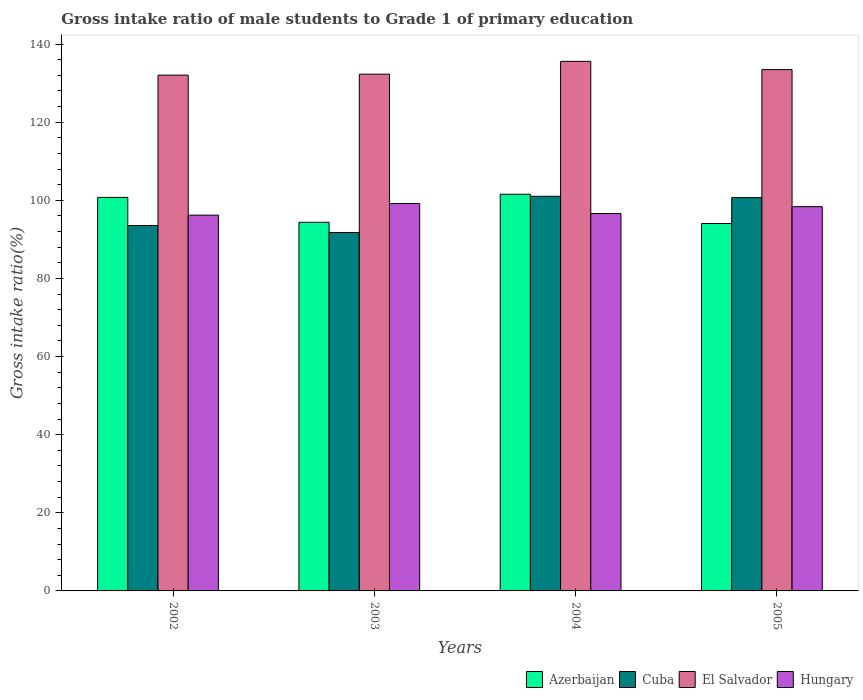How many groups of bars are there?
Make the answer very short. 4. Are the number of bars per tick equal to the number of legend labels?
Your answer should be very brief. Yes. Are the number of bars on each tick of the X-axis equal?
Provide a short and direct response. Yes. What is the gross intake ratio in Hungary in 2003?
Give a very brief answer. 99.19. Across all years, what is the maximum gross intake ratio in Cuba?
Your answer should be very brief. 101.04. Across all years, what is the minimum gross intake ratio in Cuba?
Provide a short and direct response. 91.77. In which year was the gross intake ratio in Hungary maximum?
Your answer should be very brief. 2003. In which year was the gross intake ratio in El Salvador minimum?
Offer a very short reply. 2002. What is the total gross intake ratio in Hungary in the graph?
Your answer should be compact. 390.42. What is the difference between the gross intake ratio in Cuba in 2003 and that in 2005?
Offer a very short reply. -8.93. What is the difference between the gross intake ratio in Azerbaijan in 2002 and the gross intake ratio in Hungary in 2004?
Provide a succinct answer. 4.13. What is the average gross intake ratio in El Salvador per year?
Make the answer very short. 133.36. In the year 2005, what is the difference between the gross intake ratio in Cuba and gross intake ratio in Azerbaijan?
Your response must be concise. 6.62. What is the ratio of the gross intake ratio in El Salvador in 2002 to that in 2005?
Offer a very short reply. 0.99. Is the gross intake ratio in Cuba in 2003 less than that in 2005?
Offer a very short reply. Yes. What is the difference between the highest and the second highest gross intake ratio in El Salvador?
Offer a very short reply. 2.11. What is the difference between the highest and the lowest gross intake ratio in El Salvador?
Your response must be concise. 3.52. Is the sum of the gross intake ratio in Azerbaijan in 2002 and 2003 greater than the maximum gross intake ratio in El Salvador across all years?
Your response must be concise. Yes. Is it the case that in every year, the sum of the gross intake ratio in Hungary and gross intake ratio in Cuba is greater than the sum of gross intake ratio in Azerbaijan and gross intake ratio in El Salvador?
Your response must be concise. No. What does the 4th bar from the left in 2004 represents?
Keep it short and to the point. Hungary. What does the 4th bar from the right in 2003 represents?
Your answer should be very brief. Azerbaijan. How many bars are there?
Give a very brief answer. 16. How many years are there in the graph?
Your answer should be very brief. 4. What is the difference between two consecutive major ticks on the Y-axis?
Your answer should be compact. 20. Are the values on the major ticks of Y-axis written in scientific E-notation?
Make the answer very short. No. Does the graph contain grids?
Your answer should be very brief. No. What is the title of the graph?
Offer a very short reply. Gross intake ratio of male students to Grade 1 of primary education. What is the label or title of the X-axis?
Your response must be concise. Years. What is the label or title of the Y-axis?
Your answer should be compact. Gross intake ratio(%). What is the Gross intake ratio(%) in Azerbaijan in 2002?
Provide a short and direct response. 100.76. What is the Gross intake ratio(%) of Cuba in 2002?
Provide a short and direct response. 93.56. What is the Gross intake ratio(%) of El Salvador in 2002?
Provide a short and direct response. 132.07. What is the Gross intake ratio(%) of Hungary in 2002?
Offer a very short reply. 96.21. What is the Gross intake ratio(%) in Azerbaijan in 2003?
Provide a short and direct response. 94.39. What is the Gross intake ratio(%) in Cuba in 2003?
Your answer should be compact. 91.77. What is the Gross intake ratio(%) of El Salvador in 2003?
Provide a succinct answer. 132.3. What is the Gross intake ratio(%) of Hungary in 2003?
Give a very brief answer. 99.19. What is the Gross intake ratio(%) of Azerbaijan in 2004?
Your answer should be compact. 101.56. What is the Gross intake ratio(%) in Cuba in 2004?
Provide a short and direct response. 101.04. What is the Gross intake ratio(%) of El Salvador in 2004?
Make the answer very short. 135.59. What is the Gross intake ratio(%) in Hungary in 2004?
Give a very brief answer. 96.63. What is the Gross intake ratio(%) of Azerbaijan in 2005?
Provide a succinct answer. 94.08. What is the Gross intake ratio(%) in Cuba in 2005?
Provide a succinct answer. 100.7. What is the Gross intake ratio(%) in El Salvador in 2005?
Your answer should be compact. 133.48. What is the Gross intake ratio(%) in Hungary in 2005?
Offer a very short reply. 98.39. Across all years, what is the maximum Gross intake ratio(%) of Azerbaijan?
Provide a succinct answer. 101.56. Across all years, what is the maximum Gross intake ratio(%) in Cuba?
Give a very brief answer. 101.04. Across all years, what is the maximum Gross intake ratio(%) in El Salvador?
Give a very brief answer. 135.59. Across all years, what is the maximum Gross intake ratio(%) of Hungary?
Provide a short and direct response. 99.19. Across all years, what is the minimum Gross intake ratio(%) of Azerbaijan?
Offer a terse response. 94.08. Across all years, what is the minimum Gross intake ratio(%) in Cuba?
Your response must be concise. 91.77. Across all years, what is the minimum Gross intake ratio(%) of El Salvador?
Provide a succinct answer. 132.07. Across all years, what is the minimum Gross intake ratio(%) in Hungary?
Keep it short and to the point. 96.21. What is the total Gross intake ratio(%) of Azerbaijan in the graph?
Offer a terse response. 390.78. What is the total Gross intake ratio(%) of Cuba in the graph?
Offer a very short reply. 387.07. What is the total Gross intake ratio(%) in El Salvador in the graph?
Provide a short and direct response. 533.44. What is the total Gross intake ratio(%) of Hungary in the graph?
Keep it short and to the point. 390.42. What is the difference between the Gross intake ratio(%) in Azerbaijan in 2002 and that in 2003?
Ensure brevity in your answer.  6.37. What is the difference between the Gross intake ratio(%) in Cuba in 2002 and that in 2003?
Your answer should be compact. 1.79. What is the difference between the Gross intake ratio(%) in El Salvador in 2002 and that in 2003?
Make the answer very short. -0.23. What is the difference between the Gross intake ratio(%) in Hungary in 2002 and that in 2003?
Make the answer very short. -2.97. What is the difference between the Gross intake ratio(%) in Azerbaijan in 2002 and that in 2004?
Offer a terse response. -0.81. What is the difference between the Gross intake ratio(%) of Cuba in 2002 and that in 2004?
Your answer should be very brief. -7.48. What is the difference between the Gross intake ratio(%) of El Salvador in 2002 and that in 2004?
Offer a very short reply. -3.52. What is the difference between the Gross intake ratio(%) of Hungary in 2002 and that in 2004?
Provide a short and direct response. -0.41. What is the difference between the Gross intake ratio(%) in Azerbaijan in 2002 and that in 2005?
Your answer should be very brief. 6.68. What is the difference between the Gross intake ratio(%) in Cuba in 2002 and that in 2005?
Your answer should be very brief. -7.15. What is the difference between the Gross intake ratio(%) in El Salvador in 2002 and that in 2005?
Ensure brevity in your answer.  -1.41. What is the difference between the Gross intake ratio(%) in Hungary in 2002 and that in 2005?
Provide a succinct answer. -2.17. What is the difference between the Gross intake ratio(%) in Azerbaijan in 2003 and that in 2004?
Your answer should be compact. -7.17. What is the difference between the Gross intake ratio(%) of Cuba in 2003 and that in 2004?
Your answer should be very brief. -9.27. What is the difference between the Gross intake ratio(%) in El Salvador in 2003 and that in 2004?
Offer a terse response. -3.29. What is the difference between the Gross intake ratio(%) in Hungary in 2003 and that in 2004?
Your answer should be compact. 2.56. What is the difference between the Gross intake ratio(%) in Azerbaijan in 2003 and that in 2005?
Your answer should be compact. 0.31. What is the difference between the Gross intake ratio(%) of Cuba in 2003 and that in 2005?
Your response must be concise. -8.93. What is the difference between the Gross intake ratio(%) in El Salvador in 2003 and that in 2005?
Keep it short and to the point. -1.18. What is the difference between the Gross intake ratio(%) of Hungary in 2003 and that in 2005?
Your answer should be very brief. 0.8. What is the difference between the Gross intake ratio(%) in Azerbaijan in 2004 and that in 2005?
Provide a succinct answer. 7.48. What is the difference between the Gross intake ratio(%) of Cuba in 2004 and that in 2005?
Your answer should be very brief. 0.34. What is the difference between the Gross intake ratio(%) in El Salvador in 2004 and that in 2005?
Provide a succinct answer. 2.11. What is the difference between the Gross intake ratio(%) of Hungary in 2004 and that in 2005?
Give a very brief answer. -1.76. What is the difference between the Gross intake ratio(%) of Azerbaijan in 2002 and the Gross intake ratio(%) of Cuba in 2003?
Ensure brevity in your answer.  8.99. What is the difference between the Gross intake ratio(%) in Azerbaijan in 2002 and the Gross intake ratio(%) in El Salvador in 2003?
Keep it short and to the point. -31.55. What is the difference between the Gross intake ratio(%) in Azerbaijan in 2002 and the Gross intake ratio(%) in Hungary in 2003?
Your answer should be very brief. 1.57. What is the difference between the Gross intake ratio(%) in Cuba in 2002 and the Gross intake ratio(%) in El Salvador in 2003?
Provide a short and direct response. -38.74. What is the difference between the Gross intake ratio(%) in Cuba in 2002 and the Gross intake ratio(%) in Hungary in 2003?
Make the answer very short. -5.63. What is the difference between the Gross intake ratio(%) of El Salvador in 2002 and the Gross intake ratio(%) of Hungary in 2003?
Provide a succinct answer. 32.88. What is the difference between the Gross intake ratio(%) of Azerbaijan in 2002 and the Gross intake ratio(%) of Cuba in 2004?
Ensure brevity in your answer.  -0.28. What is the difference between the Gross intake ratio(%) in Azerbaijan in 2002 and the Gross intake ratio(%) in El Salvador in 2004?
Your response must be concise. -34.83. What is the difference between the Gross intake ratio(%) in Azerbaijan in 2002 and the Gross intake ratio(%) in Hungary in 2004?
Your answer should be compact. 4.13. What is the difference between the Gross intake ratio(%) in Cuba in 2002 and the Gross intake ratio(%) in El Salvador in 2004?
Your answer should be compact. -42.03. What is the difference between the Gross intake ratio(%) of Cuba in 2002 and the Gross intake ratio(%) of Hungary in 2004?
Give a very brief answer. -3.07. What is the difference between the Gross intake ratio(%) of El Salvador in 2002 and the Gross intake ratio(%) of Hungary in 2004?
Ensure brevity in your answer.  35.44. What is the difference between the Gross intake ratio(%) in Azerbaijan in 2002 and the Gross intake ratio(%) in Cuba in 2005?
Your answer should be compact. 0.05. What is the difference between the Gross intake ratio(%) of Azerbaijan in 2002 and the Gross intake ratio(%) of El Salvador in 2005?
Provide a succinct answer. -32.72. What is the difference between the Gross intake ratio(%) in Azerbaijan in 2002 and the Gross intake ratio(%) in Hungary in 2005?
Keep it short and to the point. 2.37. What is the difference between the Gross intake ratio(%) of Cuba in 2002 and the Gross intake ratio(%) of El Salvador in 2005?
Make the answer very short. -39.92. What is the difference between the Gross intake ratio(%) of Cuba in 2002 and the Gross intake ratio(%) of Hungary in 2005?
Keep it short and to the point. -4.83. What is the difference between the Gross intake ratio(%) in El Salvador in 2002 and the Gross intake ratio(%) in Hungary in 2005?
Offer a very short reply. 33.68. What is the difference between the Gross intake ratio(%) of Azerbaijan in 2003 and the Gross intake ratio(%) of Cuba in 2004?
Make the answer very short. -6.65. What is the difference between the Gross intake ratio(%) in Azerbaijan in 2003 and the Gross intake ratio(%) in El Salvador in 2004?
Provide a succinct answer. -41.2. What is the difference between the Gross intake ratio(%) of Azerbaijan in 2003 and the Gross intake ratio(%) of Hungary in 2004?
Make the answer very short. -2.24. What is the difference between the Gross intake ratio(%) in Cuba in 2003 and the Gross intake ratio(%) in El Salvador in 2004?
Give a very brief answer. -43.82. What is the difference between the Gross intake ratio(%) of Cuba in 2003 and the Gross intake ratio(%) of Hungary in 2004?
Provide a succinct answer. -4.86. What is the difference between the Gross intake ratio(%) in El Salvador in 2003 and the Gross intake ratio(%) in Hungary in 2004?
Your answer should be compact. 35.67. What is the difference between the Gross intake ratio(%) in Azerbaijan in 2003 and the Gross intake ratio(%) in Cuba in 2005?
Your response must be concise. -6.32. What is the difference between the Gross intake ratio(%) in Azerbaijan in 2003 and the Gross intake ratio(%) in El Salvador in 2005?
Your response must be concise. -39.09. What is the difference between the Gross intake ratio(%) in Azerbaijan in 2003 and the Gross intake ratio(%) in Hungary in 2005?
Provide a succinct answer. -4. What is the difference between the Gross intake ratio(%) of Cuba in 2003 and the Gross intake ratio(%) of El Salvador in 2005?
Make the answer very short. -41.71. What is the difference between the Gross intake ratio(%) in Cuba in 2003 and the Gross intake ratio(%) in Hungary in 2005?
Your response must be concise. -6.62. What is the difference between the Gross intake ratio(%) of El Salvador in 2003 and the Gross intake ratio(%) of Hungary in 2005?
Provide a short and direct response. 33.91. What is the difference between the Gross intake ratio(%) in Azerbaijan in 2004 and the Gross intake ratio(%) in Cuba in 2005?
Your answer should be compact. 0.86. What is the difference between the Gross intake ratio(%) of Azerbaijan in 2004 and the Gross intake ratio(%) of El Salvador in 2005?
Your answer should be compact. -31.92. What is the difference between the Gross intake ratio(%) of Azerbaijan in 2004 and the Gross intake ratio(%) of Hungary in 2005?
Provide a succinct answer. 3.17. What is the difference between the Gross intake ratio(%) of Cuba in 2004 and the Gross intake ratio(%) of El Salvador in 2005?
Keep it short and to the point. -32.44. What is the difference between the Gross intake ratio(%) of Cuba in 2004 and the Gross intake ratio(%) of Hungary in 2005?
Your response must be concise. 2.65. What is the difference between the Gross intake ratio(%) in El Salvador in 2004 and the Gross intake ratio(%) in Hungary in 2005?
Your answer should be compact. 37.2. What is the average Gross intake ratio(%) of Azerbaijan per year?
Keep it short and to the point. 97.7. What is the average Gross intake ratio(%) in Cuba per year?
Offer a terse response. 96.77. What is the average Gross intake ratio(%) in El Salvador per year?
Your response must be concise. 133.36. What is the average Gross intake ratio(%) of Hungary per year?
Offer a very short reply. 97.6. In the year 2002, what is the difference between the Gross intake ratio(%) of Azerbaijan and Gross intake ratio(%) of Cuba?
Offer a terse response. 7.2. In the year 2002, what is the difference between the Gross intake ratio(%) of Azerbaijan and Gross intake ratio(%) of El Salvador?
Your response must be concise. -31.31. In the year 2002, what is the difference between the Gross intake ratio(%) of Azerbaijan and Gross intake ratio(%) of Hungary?
Make the answer very short. 4.54. In the year 2002, what is the difference between the Gross intake ratio(%) in Cuba and Gross intake ratio(%) in El Salvador?
Keep it short and to the point. -38.51. In the year 2002, what is the difference between the Gross intake ratio(%) in Cuba and Gross intake ratio(%) in Hungary?
Offer a terse response. -2.66. In the year 2002, what is the difference between the Gross intake ratio(%) of El Salvador and Gross intake ratio(%) of Hungary?
Provide a succinct answer. 35.85. In the year 2003, what is the difference between the Gross intake ratio(%) of Azerbaijan and Gross intake ratio(%) of Cuba?
Offer a very short reply. 2.62. In the year 2003, what is the difference between the Gross intake ratio(%) of Azerbaijan and Gross intake ratio(%) of El Salvador?
Offer a very short reply. -37.91. In the year 2003, what is the difference between the Gross intake ratio(%) of Azerbaijan and Gross intake ratio(%) of Hungary?
Ensure brevity in your answer.  -4.8. In the year 2003, what is the difference between the Gross intake ratio(%) of Cuba and Gross intake ratio(%) of El Salvador?
Your answer should be compact. -40.53. In the year 2003, what is the difference between the Gross intake ratio(%) of Cuba and Gross intake ratio(%) of Hungary?
Provide a succinct answer. -7.42. In the year 2003, what is the difference between the Gross intake ratio(%) of El Salvador and Gross intake ratio(%) of Hungary?
Your answer should be compact. 33.11. In the year 2004, what is the difference between the Gross intake ratio(%) of Azerbaijan and Gross intake ratio(%) of Cuba?
Ensure brevity in your answer.  0.52. In the year 2004, what is the difference between the Gross intake ratio(%) of Azerbaijan and Gross intake ratio(%) of El Salvador?
Give a very brief answer. -34.03. In the year 2004, what is the difference between the Gross intake ratio(%) of Azerbaijan and Gross intake ratio(%) of Hungary?
Your answer should be compact. 4.93. In the year 2004, what is the difference between the Gross intake ratio(%) of Cuba and Gross intake ratio(%) of El Salvador?
Your answer should be compact. -34.55. In the year 2004, what is the difference between the Gross intake ratio(%) of Cuba and Gross intake ratio(%) of Hungary?
Your answer should be compact. 4.41. In the year 2004, what is the difference between the Gross intake ratio(%) of El Salvador and Gross intake ratio(%) of Hungary?
Your answer should be very brief. 38.96. In the year 2005, what is the difference between the Gross intake ratio(%) of Azerbaijan and Gross intake ratio(%) of Cuba?
Offer a very short reply. -6.62. In the year 2005, what is the difference between the Gross intake ratio(%) of Azerbaijan and Gross intake ratio(%) of El Salvador?
Your answer should be very brief. -39.4. In the year 2005, what is the difference between the Gross intake ratio(%) of Azerbaijan and Gross intake ratio(%) of Hungary?
Your answer should be compact. -4.31. In the year 2005, what is the difference between the Gross intake ratio(%) in Cuba and Gross intake ratio(%) in El Salvador?
Keep it short and to the point. -32.78. In the year 2005, what is the difference between the Gross intake ratio(%) in Cuba and Gross intake ratio(%) in Hungary?
Your answer should be compact. 2.32. In the year 2005, what is the difference between the Gross intake ratio(%) in El Salvador and Gross intake ratio(%) in Hungary?
Your answer should be very brief. 35.09. What is the ratio of the Gross intake ratio(%) in Azerbaijan in 2002 to that in 2003?
Your response must be concise. 1.07. What is the ratio of the Gross intake ratio(%) of Cuba in 2002 to that in 2003?
Keep it short and to the point. 1.02. What is the ratio of the Gross intake ratio(%) in Cuba in 2002 to that in 2004?
Offer a very short reply. 0.93. What is the ratio of the Gross intake ratio(%) of El Salvador in 2002 to that in 2004?
Ensure brevity in your answer.  0.97. What is the ratio of the Gross intake ratio(%) of Azerbaijan in 2002 to that in 2005?
Your answer should be compact. 1.07. What is the ratio of the Gross intake ratio(%) of Cuba in 2002 to that in 2005?
Offer a very short reply. 0.93. What is the ratio of the Gross intake ratio(%) of Hungary in 2002 to that in 2005?
Offer a very short reply. 0.98. What is the ratio of the Gross intake ratio(%) in Azerbaijan in 2003 to that in 2004?
Ensure brevity in your answer.  0.93. What is the ratio of the Gross intake ratio(%) of Cuba in 2003 to that in 2004?
Ensure brevity in your answer.  0.91. What is the ratio of the Gross intake ratio(%) in El Salvador in 2003 to that in 2004?
Keep it short and to the point. 0.98. What is the ratio of the Gross intake ratio(%) of Hungary in 2003 to that in 2004?
Ensure brevity in your answer.  1.03. What is the ratio of the Gross intake ratio(%) of Azerbaijan in 2003 to that in 2005?
Your answer should be very brief. 1. What is the ratio of the Gross intake ratio(%) of Cuba in 2003 to that in 2005?
Your response must be concise. 0.91. What is the ratio of the Gross intake ratio(%) of Hungary in 2003 to that in 2005?
Offer a very short reply. 1.01. What is the ratio of the Gross intake ratio(%) in Azerbaijan in 2004 to that in 2005?
Offer a very short reply. 1.08. What is the ratio of the Gross intake ratio(%) of El Salvador in 2004 to that in 2005?
Offer a terse response. 1.02. What is the ratio of the Gross intake ratio(%) of Hungary in 2004 to that in 2005?
Your answer should be very brief. 0.98. What is the difference between the highest and the second highest Gross intake ratio(%) of Azerbaijan?
Provide a short and direct response. 0.81. What is the difference between the highest and the second highest Gross intake ratio(%) in Cuba?
Offer a very short reply. 0.34. What is the difference between the highest and the second highest Gross intake ratio(%) in El Salvador?
Offer a terse response. 2.11. What is the difference between the highest and the second highest Gross intake ratio(%) of Hungary?
Make the answer very short. 0.8. What is the difference between the highest and the lowest Gross intake ratio(%) of Azerbaijan?
Make the answer very short. 7.48. What is the difference between the highest and the lowest Gross intake ratio(%) of Cuba?
Your answer should be compact. 9.27. What is the difference between the highest and the lowest Gross intake ratio(%) in El Salvador?
Your answer should be compact. 3.52. What is the difference between the highest and the lowest Gross intake ratio(%) of Hungary?
Ensure brevity in your answer.  2.97. 